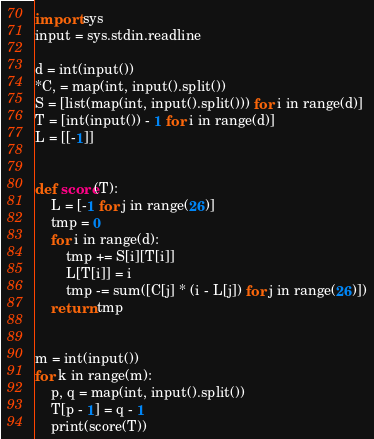<code> <loc_0><loc_0><loc_500><loc_500><_Python_>import sys
input = sys.stdin.readline

d = int(input())
*C, = map(int, input().split())
S = [list(map(int, input().split())) for i in range(d)]
T = [int(input()) - 1 for i in range(d)]
L = [[-1]]


def score(T):
    L = [-1 for j in range(26)]
    tmp = 0
    for i in range(d):
        tmp += S[i][T[i]]
        L[T[i]] = i
        tmp -= sum([C[j] * (i - L[j]) for j in range(26)])
    return tmp


m = int(input())
for k in range(m):
    p, q = map(int, input().split())
    T[p - 1] = q - 1
    print(score(T))
</code> 